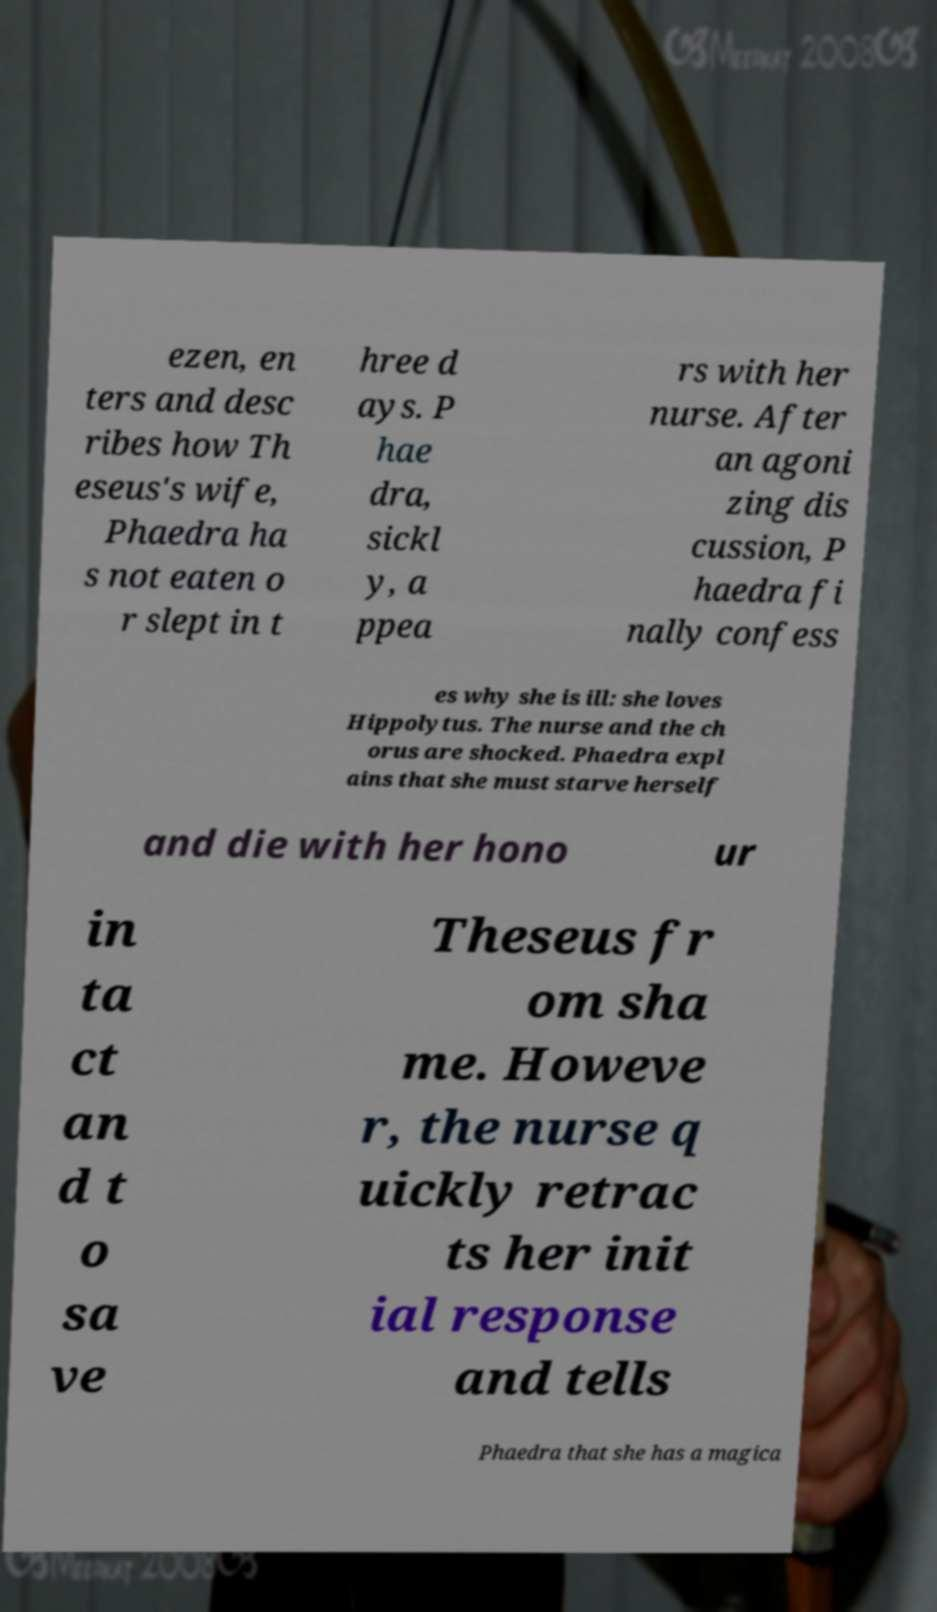There's text embedded in this image that I need extracted. Can you transcribe it verbatim? ezen, en ters and desc ribes how Th eseus's wife, Phaedra ha s not eaten o r slept in t hree d ays. P hae dra, sickl y, a ppea rs with her nurse. After an agoni zing dis cussion, P haedra fi nally confess es why she is ill: she loves Hippolytus. The nurse and the ch orus are shocked. Phaedra expl ains that she must starve herself and die with her hono ur in ta ct an d t o sa ve Theseus fr om sha me. Howeve r, the nurse q uickly retrac ts her init ial response and tells Phaedra that she has a magica 